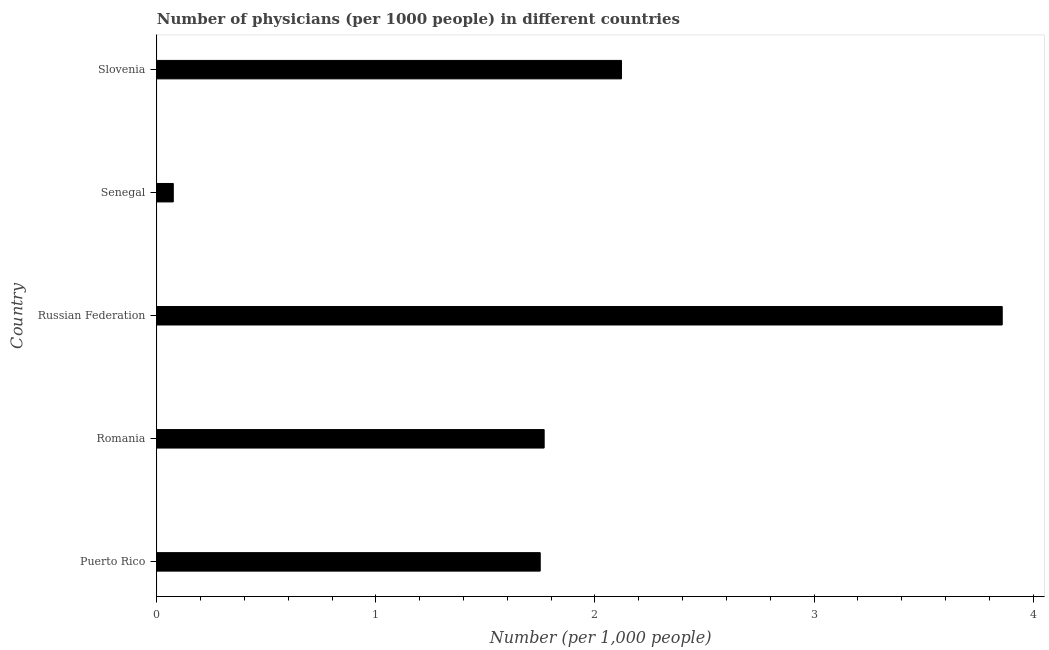Does the graph contain any zero values?
Your answer should be very brief. No. What is the title of the graph?
Keep it short and to the point. Number of physicians (per 1000 people) in different countries. What is the label or title of the X-axis?
Your response must be concise. Number (per 1,0 people). What is the number of physicians in Puerto Rico?
Keep it short and to the point. 1.75. Across all countries, what is the maximum number of physicians?
Ensure brevity in your answer.  3.86. Across all countries, what is the minimum number of physicians?
Your response must be concise. 0.07. In which country was the number of physicians maximum?
Keep it short and to the point. Russian Federation. In which country was the number of physicians minimum?
Your answer should be compact. Senegal. What is the sum of the number of physicians?
Keep it short and to the point. 9.57. What is the difference between the number of physicians in Russian Federation and Senegal?
Provide a succinct answer. 3.78. What is the average number of physicians per country?
Make the answer very short. 1.92. What is the median number of physicians?
Provide a short and direct response. 1.77. What is the ratio of the number of physicians in Puerto Rico to that in Slovenia?
Ensure brevity in your answer.  0.82. What is the difference between the highest and the second highest number of physicians?
Your answer should be compact. 1.74. What is the difference between the highest and the lowest number of physicians?
Keep it short and to the point. 3.78. What is the difference between two consecutive major ticks on the X-axis?
Provide a succinct answer. 1. Are the values on the major ticks of X-axis written in scientific E-notation?
Provide a short and direct response. No. What is the Number (per 1,000 people) in Puerto Rico?
Offer a terse response. 1.75. What is the Number (per 1,000 people) in Romania?
Provide a short and direct response. 1.77. What is the Number (per 1,000 people) in Russian Federation?
Offer a terse response. 3.86. What is the Number (per 1,000 people) of Senegal?
Your answer should be compact. 0.07. What is the Number (per 1,000 people) of Slovenia?
Provide a short and direct response. 2.12. What is the difference between the Number (per 1,000 people) in Puerto Rico and Romania?
Give a very brief answer. -0.02. What is the difference between the Number (per 1,000 people) in Puerto Rico and Russian Federation?
Offer a terse response. -2.11. What is the difference between the Number (per 1,000 people) in Puerto Rico and Senegal?
Provide a short and direct response. 1.68. What is the difference between the Number (per 1,000 people) in Puerto Rico and Slovenia?
Provide a short and direct response. -0.37. What is the difference between the Number (per 1,000 people) in Romania and Russian Federation?
Offer a very short reply. -2.09. What is the difference between the Number (per 1,000 people) in Romania and Senegal?
Provide a short and direct response. 1.69. What is the difference between the Number (per 1,000 people) in Romania and Slovenia?
Keep it short and to the point. -0.35. What is the difference between the Number (per 1,000 people) in Russian Federation and Senegal?
Keep it short and to the point. 3.78. What is the difference between the Number (per 1,000 people) in Russian Federation and Slovenia?
Offer a terse response. 1.74. What is the difference between the Number (per 1,000 people) in Senegal and Slovenia?
Offer a very short reply. -2.05. What is the ratio of the Number (per 1,000 people) in Puerto Rico to that in Romania?
Your answer should be compact. 0.99. What is the ratio of the Number (per 1,000 people) in Puerto Rico to that in Russian Federation?
Give a very brief answer. 0.45. What is the ratio of the Number (per 1,000 people) in Puerto Rico to that in Senegal?
Give a very brief answer. 23.33. What is the ratio of the Number (per 1,000 people) in Puerto Rico to that in Slovenia?
Your answer should be very brief. 0.82. What is the ratio of the Number (per 1,000 people) in Romania to that in Russian Federation?
Give a very brief answer. 0.46. What is the ratio of the Number (per 1,000 people) in Romania to that in Senegal?
Provide a succinct answer. 23.57. What is the ratio of the Number (per 1,000 people) in Romania to that in Slovenia?
Ensure brevity in your answer.  0.83. What is the ratio of the Number (per 1,000 people) in Russian Federation to that in Senegal?
Make the answer very short. 51.45. What is the ratio of the Number (per 1,000 people) in Russian Federation to that in Slovenia?
Ensure brevity in your answer.  1.82. What is the ratio of the Number (per 1,000 people) in Senegal to that in Slovenia?
Make the answer very short. 0.04. 